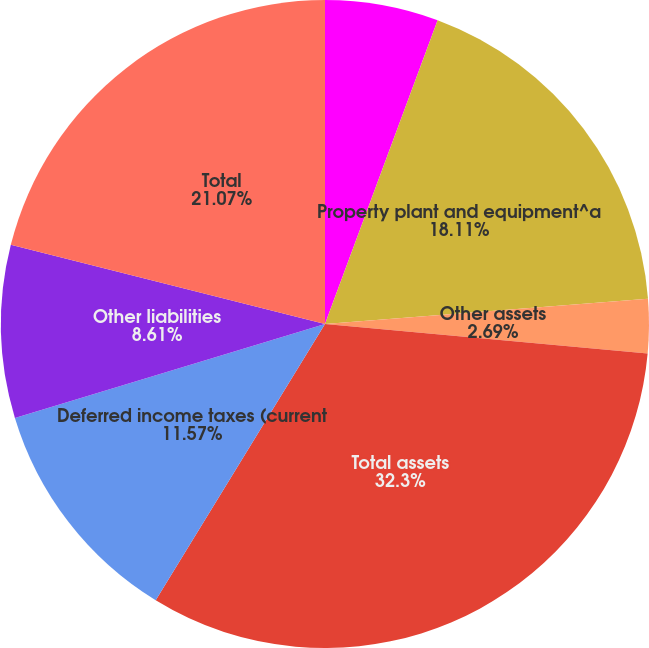<chart> <loc_0><loc_0><loc_500><loc_500><pie_chart><fcel>Inventories including mill and<fcel>Property plant and equipment^a<fcel>Other assets<fcel>Total assets<fcel>Deferred income taxes (current<fcel>Other liabilities<fcel>Total<nl><fcel>5.65%<fcel>18.11%<fcel>2.69%<fcel>32.3%<fcel>11.57%<fcel>8.61%<fcel>21.07%<nl></chart> 